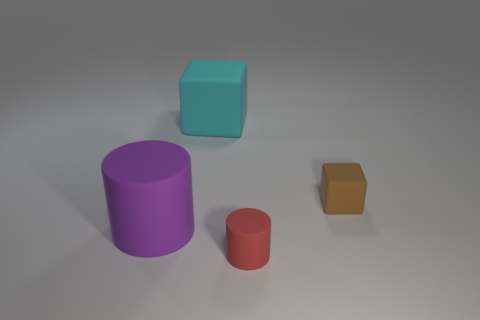Add 4 green spheres. How many objects exist? 8 Add 2 matte objects. How many matte objects are left? 6 Add 2 red rubber objects. How many red rubber objects exist? 3 Subtract 0 gray cylinders. How many objects are left? 4 Subtract all large rubber cylinders. Subtract all red rubber things. How many objects are left? 2 